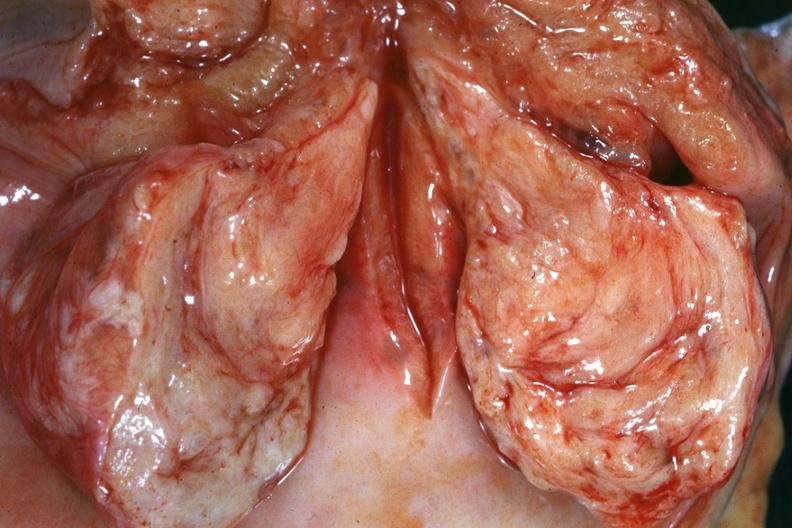s cervical leiomyoma present?
Answer the question using a single word or phrase. Yes 